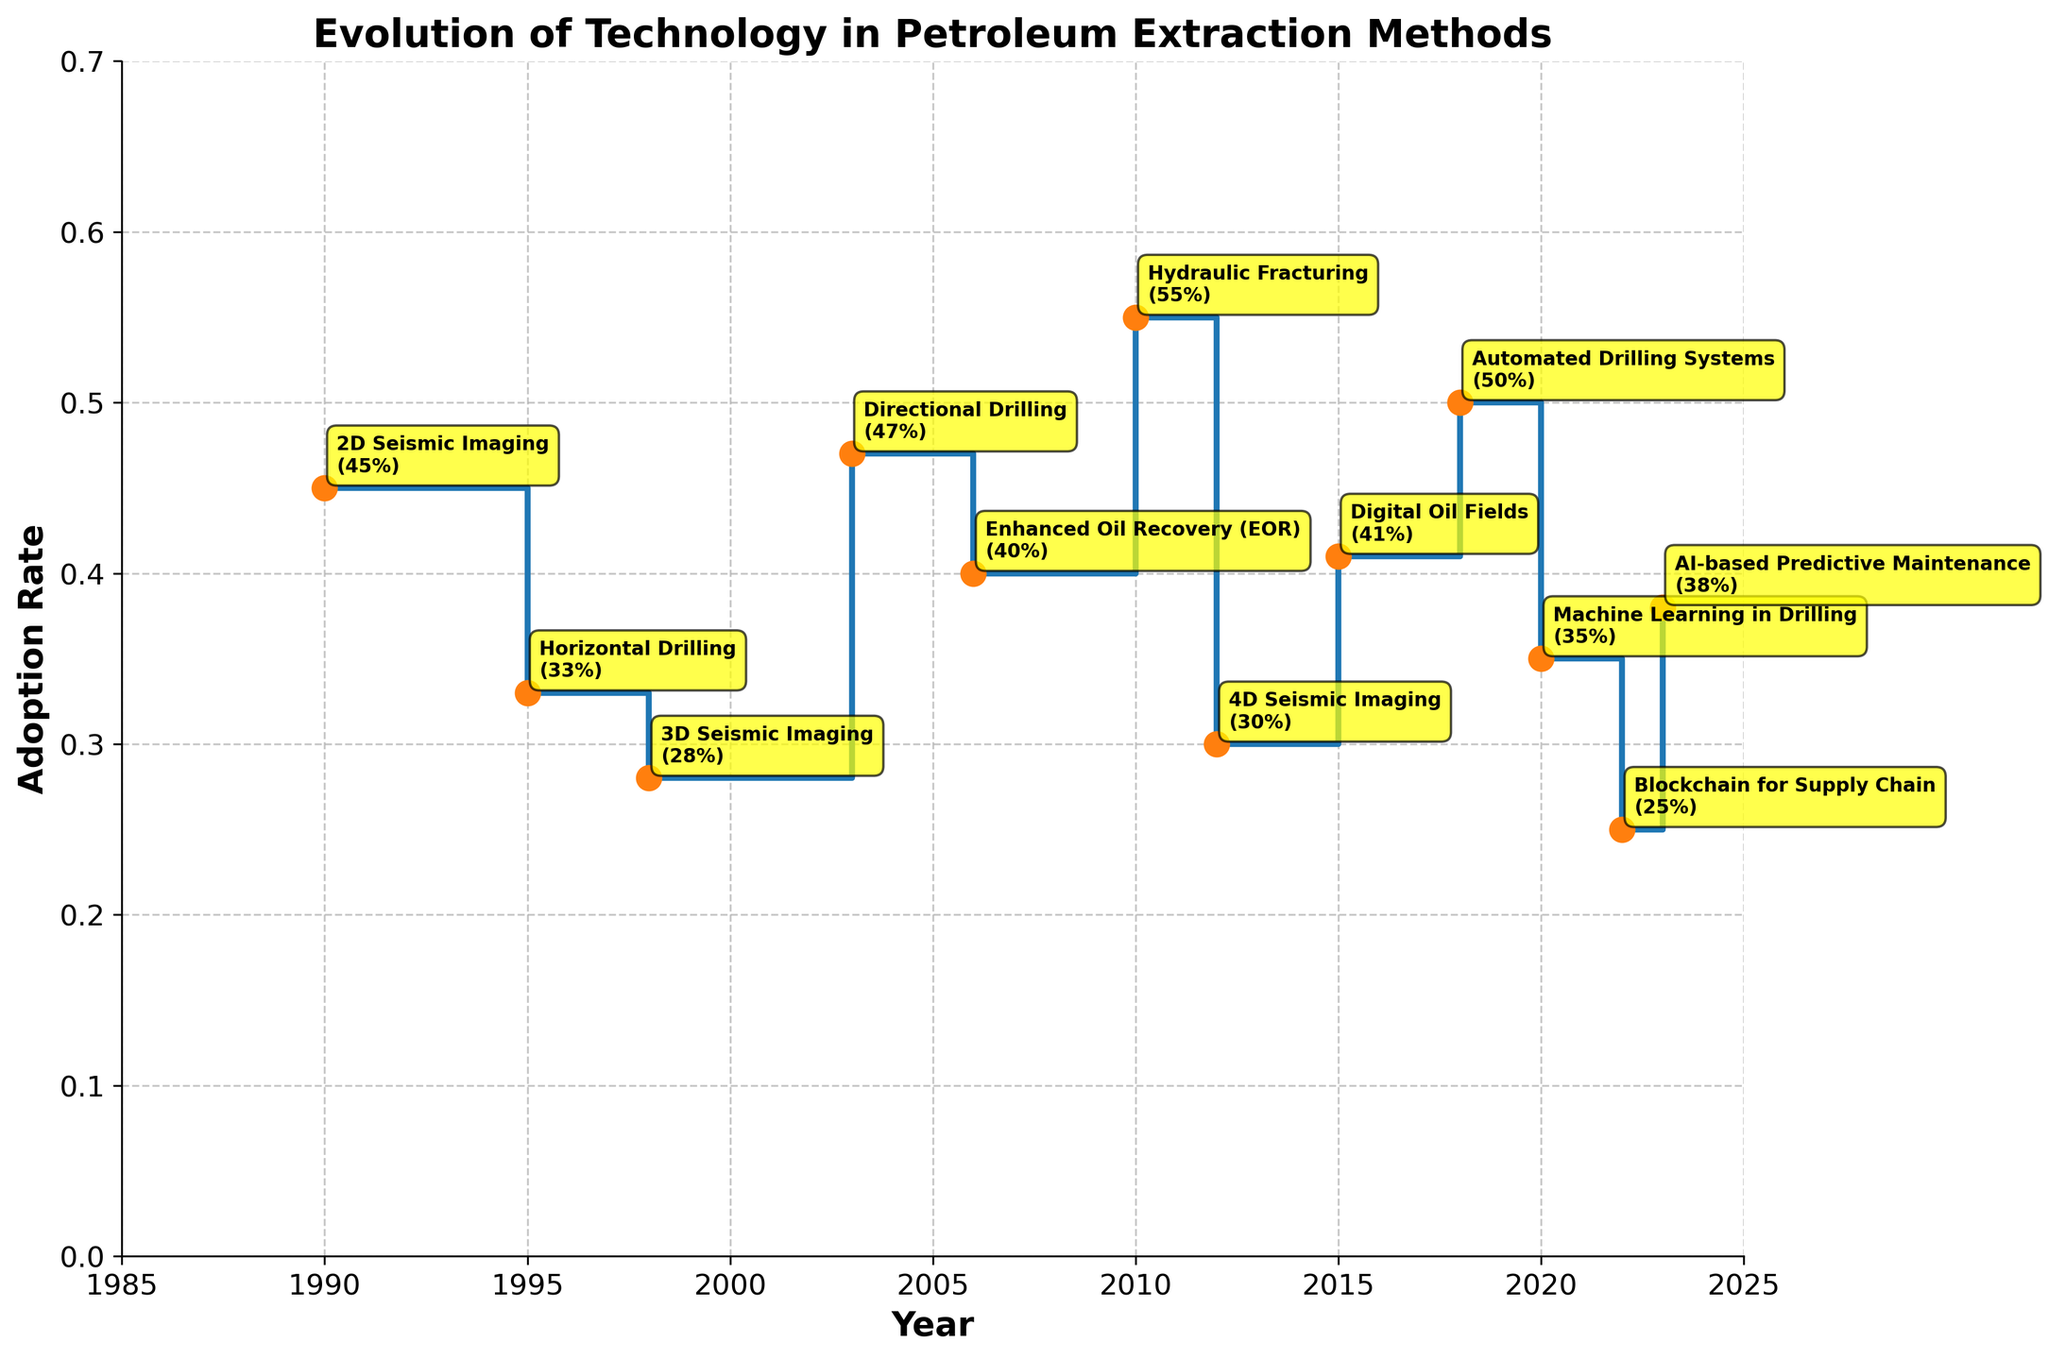What is the title of the chart? The title is usually located at the top of the chart, summarizing the main subject. In this case, it reads "Evolution of Technology in Petroleum Extraction Methods."
Answer: Evolution of Technology in Petroleum Extraction Methods What is the highest adoption rate shown on the chart, and in which year? The highest adoption rate is determined by looking for the maximum y-value on the adoption rate axis. The year corresponding to that maximum value should be noted. The highest adoption rate is 0.55 in the year 2010.
Answer: 0.55 in 2010 Which technology had the lowest adoption rate, and what was the rate? The lowest adoption rate can be identified by finding the smallest y-value and observing the corresponding technology annotation. Blockchain for Supply Chain had the lowest adoption rate at 0.25 in 2022.
Answer: Blockchain for Supply Chain at 0.25 How many technologies reached at least a 0.40 adoption rate? To determine this, count the number of technologies with adoption rates greater than or equal to 0.40.
Answer: 6 technologies Which years had an adoption rate of exactly 0.40, and for which technologies? Scan the chart for points where the adoption rate is exactly 0.40 and identify the associated years and technologies. For 2006, the technology is Enhanced Oil Recovery (EOR).
Answer: 2006 for Enhanced Oil Recovery (EOR) What is the difference in adoption rates between Hydraulic Fracturing (2010) and Machine Learning in Drilling (2020)? Find the adoption rates for both Hydraulic Fracturing (0.55) and Machine Learning in Drilling (0.35), then subtract the latter from the former. The difference is 0.20.
Answer: 0.20 Which technology showed the most recent adoption, and what was its adoption rate? The most recent adoption can be identified by finding the technology with the latest year (2023) and noting its adoption rate. AI-based Predictive Maintenance in 2023 had an adoption rate of 0.38.
Answer: AI-based Predictive Maintenance at 0.38 In which years did the adoption rate of new technologies surpass 0.45? Look for years where the horizontal steps exceed 0.45 on the y-axis. The adoption rate surpassed 0.45 in the years of 1990 (2D Seismic Imaging), 2003 (Directional Drilling), 2010 (Hydraulic Fracturing), 2018 (Automated Drilling Systems).
Answer: 1990, 2003, 2010, 2018 Compare the adoption rates of Horizontal Drilling (1995) and Directional Drilling (2003). Which had a higher adoption rate, and what is the difference? Locate the adoption rates for Horizontal Drilling (0.33) in 1995 and Directional Drilling (0.47) in 2003; then compare them and note the difference. Directional Drilling had a higher rate, with a difference of 0.14.
Answer: Directional Drilling (0.47) had a higher rate by 0.14 What is the average adoption rate across all the technologies shown? The average adoption rate is calculated by summing all the adoption rates and dividing by the number of technologies (12). Calculation: (0.45 + 0.33 + 0.28 + 0.47 + 0.40 + 0.55 + 0.30 + 0.41 + 0.50 + 0.35 + 0.25 + 0.38) / 12 = 0.39
Answer: 0.39 